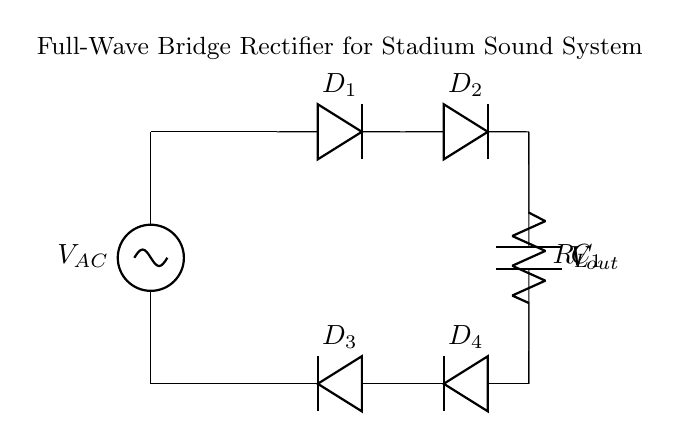What type of rectifier is shown in the circuit? The circuit is a full-wave bridge rectifier because it uses four diodes arranged in a bridge configuration to convert AC to DC.
Answer: full-wave bridge rectifier How many diodes are in this circuit? There are four diodes (D1, D2, D3, and D4) in the bridge rectifier. Each diode allows current to pass during one cycle of the input AC signal.
Answer: four What is the purpose of the smoothing capacitor? The smoothing capacitor (C1) is used to reduce the ripple in the output voltage by storing charge and releasing it to maintain a steady voltage level across the load resistor.
Answer: reduce ripple What is the function of the load resistor in this circuit? The load resistor (RL) is where the output voltage is applied, and it draws current from the rectified voltage, allowing the circuit to power a load like a speaker in a sound system.
Answer: power the load What happens to the output voltage if the AC input voltage increases? If the AC input voltage increases, the output voltage (Vout) will also increase proportionally, assuming the diodes and other circuit components can handle the higher voltage without failure.
Answer: increase Why are the diodes oriented as such in this circuit? The diodes are oriented in the bridge arrangement to allow current to flow in both directions of the AC cycle, ensuring that both halves of the AC signal contribute to the output, resulting in full-wave rectification.
Answer: full-wave rectification 